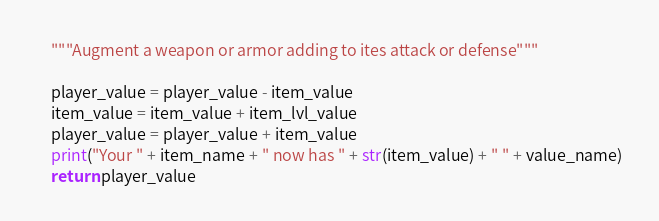Convert code to text. <code><loc_0><loc_0><loc_500><loc_500><_Python_>	"""Augment a weapon or armor adding to ites attack or defense"""
	
	player_value = player_value - item_value
	item_value = item_value + item_lvl_value
	player_value = player_value + item_value
	print("Your " + item_name + " now has " + str(item_value) + " " + value_name)
	return player_value
</code> 